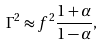Convert formula to latex. <formula><loc_0><loc_0><loc_500><loc_500>\Gamma ^ { 2 } \approx f ^ { 2 } \frac { 1 + \alpha } { 1 - \alpha } ,</formula> 